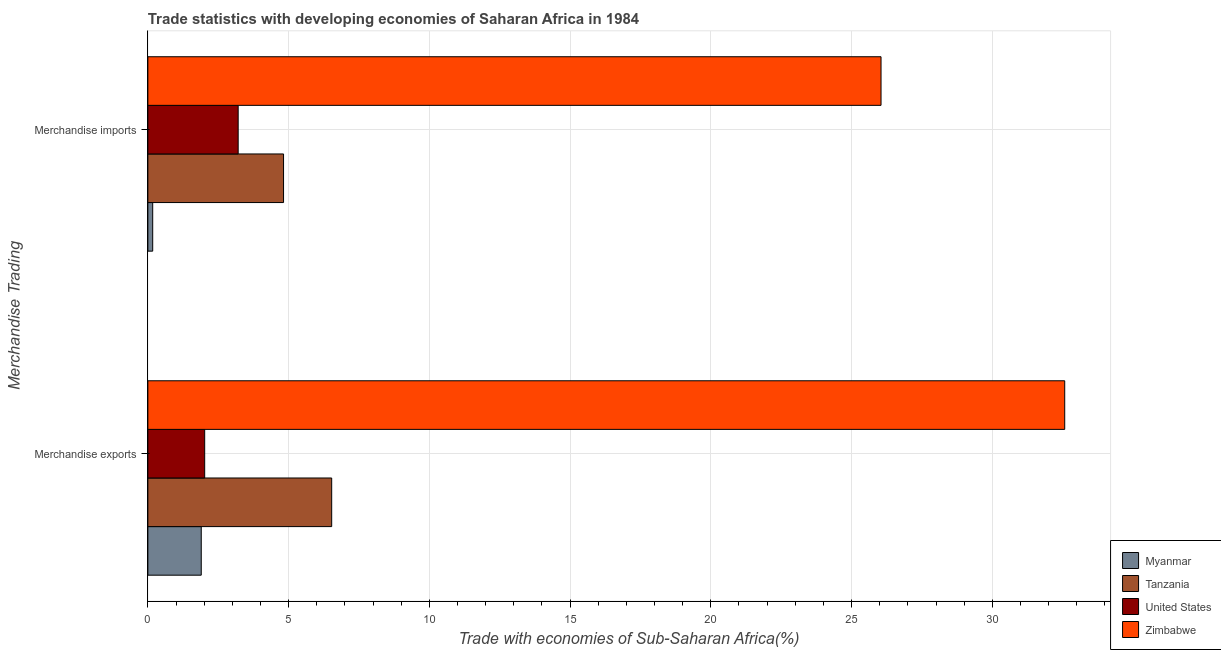How many different coloured bars are there?
Provide a succinct answer. 4. How many bars are there on the 2nd tick from the top?
Provide a short and direct response. 4. What is the label of the 1st group of bars from the top?
Provide a succinct answer. Merchandise imports. What is the merchandise exports in Zimbabwe?
Ensure brevity in your answer.  32.57. Across all countries, what is the maximum merchandise exports?
Ensure brevity in your answer.  32.57. Across all countries, what is the minimum merchandise imports?
Your answer should be compact. 0.17. In which country was the merchandise imports maximum?
Keep it short and to the point. Zimbabwe. In which country was the merchandise imports minimum?
Keep it short and to the point. Myanmar. What is the total merchandise exports in the graph?
Offer a terse response. 43.02. What is the difference between the merchandise imports in Tanzania and that in United States?
Provide a succinct answer. 1.61. What is the difference between the merchandise imports in Myanmar and the merchandise exports in United States?
Your answer should be very brief. -1.85. What is the average merchandise exports per country?
Offer a very short reply. 10.75. What is the difference between the merchandise imports and merchandise exports in Myanmar?
Keep it short and to the point. -1.72. In how many countries, is the merchandise imports greater than 18 %?
Offer a terse response. 1. What is the ratio of the merchandise imports in United States to that in Zimbabwe?
Your answer should be compact. 0.12. In how many countries, is the merchandise exports greater than the average merchandise exports taken over all countries?
Provide a short and direct response. 1. What does the 3rd bar from the top in Merchandise exports represents?
Make the answer very short. Tanzania. What does the 4th bar from the bottom in Merchandise imports represents?
Your response must be concise. Zimbabwe. How many bars are there?
Ensure brevity in your answer.  8. What is the difference between two consecutive major ticks on the X-axis?
Provide a short and direct response. 5. Where does the legend appear in the graph?
Keep it short and to the point. Bottom right. What is the title of the graph?
Offer a very short reply. Trade statistics with developing economies of Saharan Africa in 1984. What is the label or title of the X-axis?
Provide a short and direct response. Trade with economies of Sub-Saharan Africa(%). What is the label or title of the Y-axis?
Provide a short and direct response. Merchandise Trading. What is the Trade with economies of Sub-Saharan Africa(%) in Myanmar in Merchandise exports?
Make the answer very short. 1.9. What is the Trade with economies of Sub-Saharan Africa(%) in Tanzania in Merchandise exports?
Offer a terse response. 6.53. What is the Trade with economies of Sub-Saharan Africa(%) of United States in Merchandise exports?
Give a very brief answer. 2.02. What is the Trade with economies of Sub-Saharan Africa(%) in Zimbabwe in Merchandise exports?
Provide a short and direct response. 32.57. What is the Trade with economies of Sub-Saharan Africa(%) in Myanmar in Merchandise imports?
Ensure brevity in your answer.  0.17. What is the Trade with economies of Sub-Saharan Africa(%) of Tanzania in Merchandise imports?
Make the answer very short. 4.82. What is the Trade with economies of Sub-Saharan Africa(%) in United States in Merchandise imports?
Your answer should be very brief. 3.21. What is the Trade with economies of Sub-Saharan Africa(%) of Zimbabwe in Merchandise imports?
Offer a very short reply. 26.05. Across all Merchandise Trading, what is the maximum Trade with economies of Sub-Saharan Africa(%) of Myanmar?
Ensure brevity in your answer.  1.9. Across all Merchandise Trading, what is the maximum Trade with economies of Sub-Saharan Africa(%) of Tanzania?
Your answer should be very brief. 6.53. Across all Merchandise Trading, what is the maximum Trade with economies of Sub-Saharan Africa(%) in United States?
Ensure brevity in your answer.  3.21. Across all Merchandise Trading, what is the maximum Trade with economies of Sub-Saharan Africa(%) of Zimbabwe?
Provide a succinct answer. 32.57. Across all Merchandise Trading, what is the minimum Trade with economies of Sub-Saharan Africa(%) in Myanmar?
Offer a terse response. 0.17. Across all Merchandise Trading, what is the minimum Trade with economies of Sub-Saharan Africa(%) in Tanzania?
Ensure brevity in your answer.  4.82. Across all Merchandise Trading, what is the minimum Trade with economies of Sub-Saharan Africa(%) of United States?
Your response must be concise. 2.02. Across all Merchandise Trading, what is the minimum Trade with economies of Sub-Saharan Africa(%) of Zimbabwe?
Make the answer very short. 26.05. What is the total Trade with economies of Sub-Saharan Africa(%) in Myanmar in the graph?
Provide a short and direct response. 2.07. What is the total Trade with economies of Sub-Saharan Africa(%) in Tanzania in the graph?
Your response must be concise. 11.35. What is the total Trade with economies of Sub-Saharan Africa(%) of United States in the graph?
Your answer should be compact. 5.23. What is the total Trade with economies of Sub-Saharan Africa(%) of Zimbabwe in the graph?
Your response must be concise. 58.62. What is the difference between the Trade with economies of Sub-Saharan Africa(%) in Myanmar in Merchandise exports and that in Merchandise imports?
Give a very brief answer. 1.72. What is the difference between the Trade with economies of Sub-Saharan Africa(%) in Tanzania in Merchandise exports and that in Merchandise imports?
Your response must be concise. 1.71. What is the difference between the Trade with economies of Sub-Saharan Africa(%) in United States in Merchandise exports and that in Merchandise imports?
Your answer should be compact. -1.19. What is the difference between the Trade with economies of Sub-Saharan Africa(%) in Zimbabwe in Merchandise exports and that in Merchandise imports?
Give a very brief answer. 6.53. What is the difference between the Trade with economies of Sub-Saharan Africa(%) in Myanmar in Merchandise exports and the Trade with economies of Sub-Saharan Africa(%) in Tanzania in Merchandise imports?
Your answer should be very brief. -2.92. What is the difference between the Trade with economies of Sub-Saharan Africa(%) of Myanmar in Merchandise exports and the Trade with economies of Sub-Saharan Africa(%) of United States in Merchandise imports?
Offer a very short reply. -1.31. What is the difference between the Trade with economies of Sub-Saharan Africa(%) in Myanmar in Merchandise exports and the Trade with economies of Sub-Saharan Africa(%) in Zimbabwe in Merchandise imports?
Provide a short and direct response. -24.15. What is the difference between the Trade with economies of Sub-Saharan Africa(%) in Tanzania in Merchandise exports and the Trade with economies of Sub-Saharan Africa(%) in United States in Merchandise imports?
Offer a terse response. 3.32. What is the difference between the Trade with economies of Sub-Saharan Africa(%) of Tanzania in Merchandise exports and the Trade with economies of Sub-Saharan Africa(%) of Zimbabwe in Merchandise imports?
Keep it short and to the point. -19.52. What is the difference between the Trade with economies of Sub-Saharan Africa(%) of United States in Merchandise exports and the Trade with economies of Sub-Saharan Africa(%) of Zimbabwe in Merchandise imports?
Provide a short and direct response. -24.03. What is the average Trade with economies of Sub-Saharan Africa(%) of Myanmar per Merchandise Trading?
Your answer should be compact. 1.03. What is the average Trade with economies of Sub-Saharan Africa(%) of Tanzania per Merchandise Trading?
Keep it short and to the point. 5.68. What is the average Trade with economies of Sub-Saharan Africa(%) in United States per Merchandise Trading?
Provide a succinct answer. 2.61. What is the average Trade with economies of Sub-Saharan Africa(%) of Zimbabwe per Merchandise Trading?
Offer a terse response. 29.31. What is the difference between the Trade with economies of Sub-Saharan Africa(%) of Myanmar and Trade with economies of Sub-Saharan Africa(%) of Tanzania in Merchandise exports?
Keep it short and to the point. -4.63. What is the difference between the Trade with economies of Sub-Saharan Africa(%) in Myanmar and Trade with economies of Sub-Saharan Africa(%) in United States in Merchandise exports?
Provide a short and direct response. -0.12. What is the difference between the Trade with economies of Sub-Saharan Africa(%) of Myanmar and Trade with economies of Sub-Saharan Africa(%) of Zimbabwe in Merchandise exports?
Your answer should be very brief. -30.68. What is the difference between the Trade with economies of Sub-Saharan Africa(%) in Tanzania and Trade with economies of Sub-Saharan Africa(%) in United States in Merchandise exports?
Give a very brief answer. 4.51. What is the difference between the Trade with economies of Sub-Saharan Africa(%) in Tanzania and Trade with economies of Sub-Saharan Africa(%) in Zimbabwe in Merchandise exports?
Provide a short and direct response. -26.04. What is the difference between the Trade with economies of Sub-Saharan Africa(%) in United States and Trade with economies of Sub-Saharan Africa(%) in Zimbabwe in Merchandise exports?
Provide a succinct answer. -30.55. What is the difference between the Trade with economies of Sub-Saharan Africa(%) in Myanmar and Trade with economies of Sub-Saharan Africa(%) in Tanzania in Merchandise imports?
Offer a terse response. -4.65. What is the difference between the Trade with economies of Sub-Saharan Africa(%) in Myanmar and Trade with economies of Sub-Saharan Africa(%) in United States in Merchandise imports?
Make the answer very short. -3.04. What is the difference between the Trade with economies of Sub-Saharan Africa(%) in Myanmar and Trade with economies of Sub-Saharan Africa(%) in Zimbabwe in Merchandise imports?
Your answer should be very brief. -25.87. What is the difference between the Trade with economies of Sub-Saharan Africa(%) of Tanzania and Trade with economies of Sub-Saharan Africa(%) of United States in Merchandise imports?
Provide a succinct answer. 1.61. What is the difference between the Trade with economies of Sub-Saharan Africa(%) in Tanzania and Trade with economies of Sub-Saharan Africa(%) in Zimbabwe in Merchandise imports?
Offer a terse response. -21.23. What is the difference between the Trade with economies of Sub-Saharan Africa(%) of United States and Trade with economies of Sub-Saharan Africa(%) of Zimbabwe in Merchandise imports?
Ensure brevity in your answer.  -22.84. What is the ratio of the Trade with economies of Sub-Saharan Africa(%) of Myanmar in Merchandise exports to that in Merchandise imports?
Provide a short and direct response. 11.03. What is the ratio of the Trade with economies of Sub-Saharan Africa(%) of Tanzania in Merchandise exports to that in Merchandise imports?
Your response must be concise. 1.35. What is the ratio of the Trade with economies of Sub-Saharan Africa(%) of United States in Merchandise exports to that in Merchandise imports?
Make the answer very short. 0.63. What is the ratio of the Trade with economies of Sub-Saharan Africa(%) in Zimbabwe in Merchandise exports to that in Merchandise imports?
Offer a terse response. 1.25. What is the difference between the highest and the second highest Trade with economies of Sub-Saharan Africa(%) in Myanmar?
Provide a succinct answer. 1.72. What is the difference between the highest and the second highest Trade with economies of Sub-Saharan Africa(%) in Tanzania?
Offer a terse response. 1.71. What is the difference between the highest and the second highest Trade with economies of Sub-Saharan Africa(%) of United States?
Keep it short and to the point. 1.19. What is the difference between the highest and the second highest Trade with economies of Sub-Saharan Africa(%) of Zimbabwe?
Keep it short and to the point. 6.53. What is the difference between the highest and the lowest Trade with economies of Sub-Saharan Africa(%) in Myanmar?
Make the answer very short. 1.72. What is the difference between the highest and the lowest Trade with economies of Sub-Saharan Africa(%) in Tanzania?
Make the answer very short. 1.71. What is the difference between the highest and the lowest Trade with economies of Sub-Saharan Africa(%) in United States?
Make the answer very short. 1.19. What is the difference between the highest and the lowest Trade with economies of Sub-Saharan Africa(%) in Zimbabwe?
Offer a terse response. 6.53. 